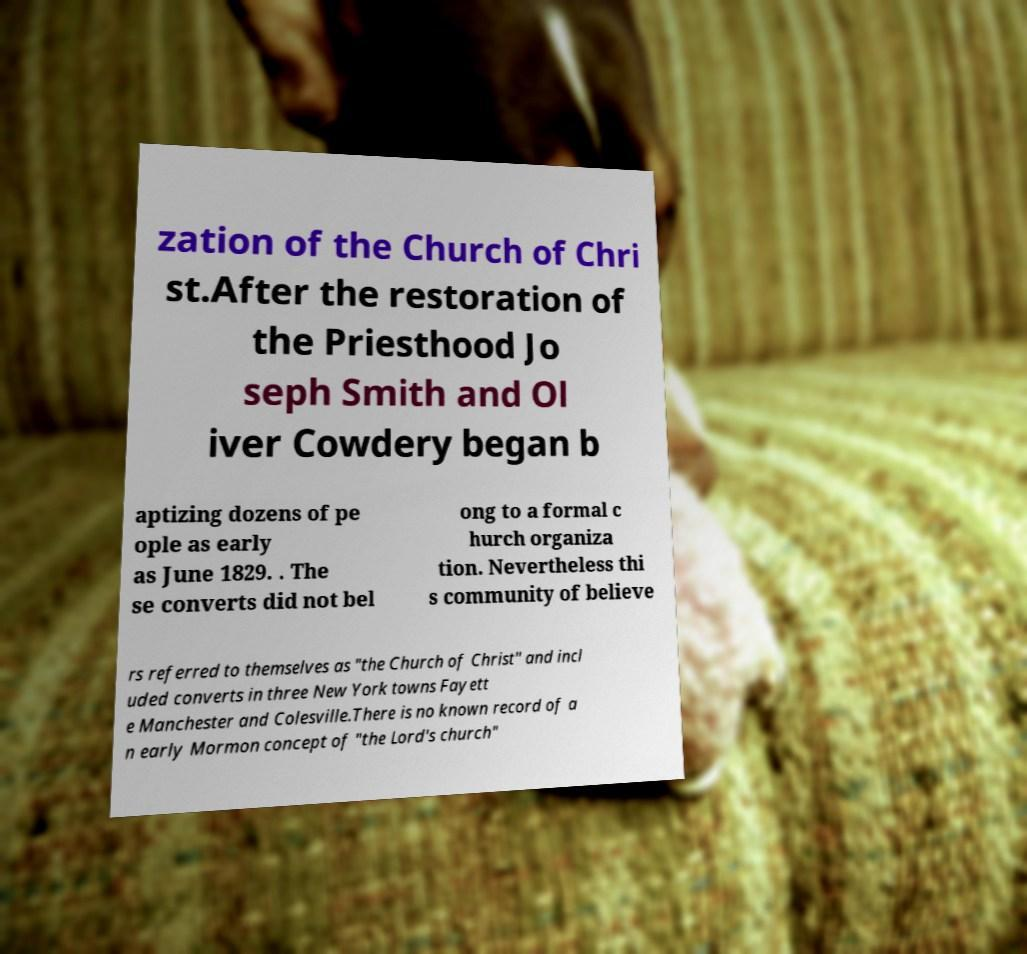Could you assist in decoding the text presented in this image and type it out clearly? zation of the Church of Chri st.After the restoration of the Priesthood Jo seph Smith and Ol iver Cowdery began b aptizing dozens of pe ople as early as June 1829. . The se converts did not bel ong to a formal c hurch organiza tion. Nevertheless thi s community of believe rs referred to themselves as "the Church of Christ" and incl uded converts in three New York towns Fayett e Manchester and Colesville.There is no known record of a n early Mormon concept of "the Lord's church" 